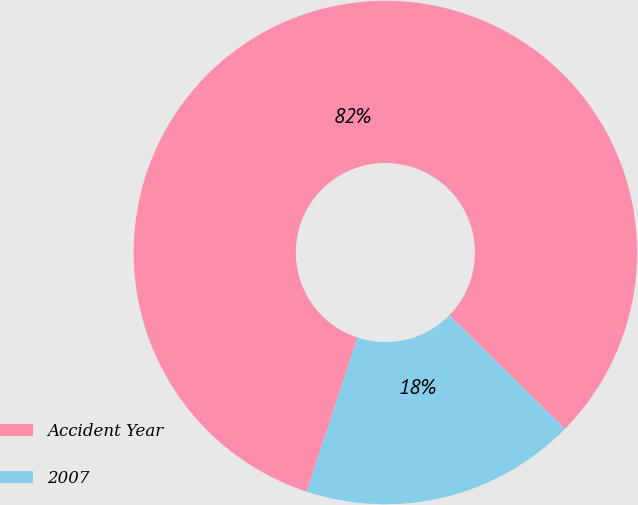<chart> <loc_0><loc_0><loc_500><loc_500><pie_chart><fcel>Accident Year<fcel>2007<nl><fcel>82.3%<fcel>17.7%<nl></chart> 